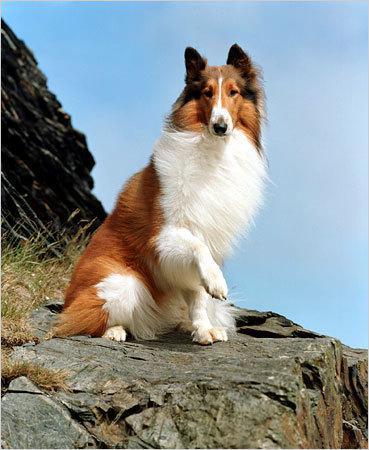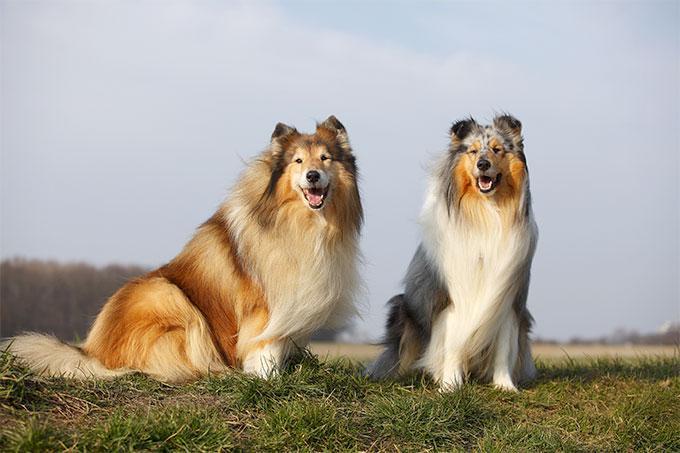The first image is the image on the left, the second image is the image on the right. Analyze the images presented: Is the assertion "There are three dogs outside." valid? Answer yes or no. Yes. 